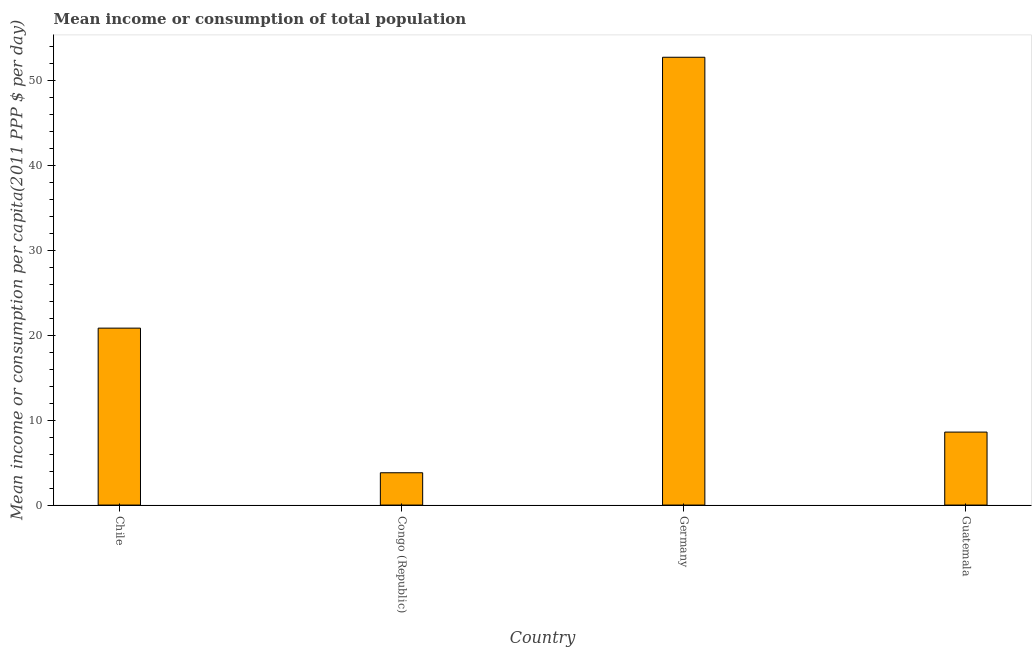Does the graph contain any zero values?
Make the answer very short. No. What is the title of the graph?
Provide a short and direct response. Mean income or consumption of total population. What is the label or title of the X-axis?
Keep it short and to the point. Country. What is the label or title of the Y-axis?
Provide a succinct answer. Mean income or consumption per capita(2011 PPP $ per day). What is the mean income or consumption in Guatemala?
Make the answer very short. 8.6. Across all countries, what is the maximum mean income or consumption?
Offer a very short reply. 52.79. Across all countries, what is the minimum mean income or consumption?
Your answer should be very brief. 3.81. In which country was the mean income or consumption maximum?
Provide a succinct answer. Germany. In which country was the mean income or consumption minimum?
Ensure brevity in your answer.  Congo (Republic). What is the sum of the mean income or consumption?
Offer a terse response. 86.06. What is the difference between the mean income or consumption in Germany and Guatemala?
Ensure brevity in your answer.  44.19. What is the average mean income or consumption per country?
Keep it short and to the point. 21.52. What is the median mean income or consumption?
Keep it short and to the point. 14.73. In how many countries, is the mean income or consumption greater than 24 $?
Your answer should be compact. 1. What is the ratio of the mean income or consumption in Congo (Republic) to that in Germany?
Your response must be concise. 0.07. Is the mean income or consumption in Chile less than that in Congo (Republic)?
Ensure brevity in your answer.  No. Is the difference between the mean income or consumption in Germany and Guatemala greater than the difference between any two countries?
Make the answer very short. No. What is the difference between the highest and the second highest mean income or consumption?
Your response must be concise. 31.93. What is the difference between the highest and the lowest mean income or consumption?
Offer a terse response. 48.98. How many bars are there?
Ensure brevity in your answer.  4. Are all the bars in the graph horizontal?
Give a very brief answer. No. What is the difference between two consecutive major ticks on the Y-axis?
Give a very brief answer. 10. Are the values on the major ticks of Y-axis written in scientific E-notation?
Your response must be concise. No. What is the Mean income or consumption per capita(2011 PPP $ per day) of Chile?
Your answer should be compact. 20.86. What is the Mean income or consumption per capita(2011 PPP $ per day) in Congo (Republic)?
Offer a very short reply. 3.81. What is the Mean income or consumption per capita(2011 PPP $ per day) of Germany?
Keep it short and to the point. 52.79. What is the Mean income or consumption per capita(2011 PPP $ per day) in Guatemala?
Keep it short and to the point. 8.6. What is the difference between the Mean income or consumption per capita(2011 PPP $ per day) in Chile and Congo (Republic)?
Make the answer very short. 17.05. What is the difference between the Mean income or consumption per capita(2011 PPP $ per day) in Chile and Germany?
Offer a very short reply. -31.93. What is the difference between the Mean income or consumption per capita(2011 PPP $ per day) in Chile and Guatemala?
Ensure brevity in your answer.  12.25. What is the difference between the Mean income or consumption per capita(2011 PPP $ per day) in Congo (Republic) and Germany?
Your answer should be very brief. -48.98. What is the difference between the Mean income or consumption per capita(2011 PPP $ per day) in Congo (Republic) and Guatemala?
Provide a succinct answer. -4.79. What is the difference between the Mean income or consumption per capita(2011 PPP $ per day) in Germany and Guatemala?
Your answer should be very brief. 44.19. What is the ratio of the Mean income or consumption per capita(2011 PPP $ per day) in Chile to that in Congo (Republic)?
Your answer should be very brief. 5.47. What is the ratio of the Mean income or consumption per capita(2011 PPP $ per day) in Chile to that in Germany?
Your answer should be compact. 0.4. What is the ratio of the Mean income or consumption per capita(2011 PPP $ per day) in Chile to that in Guatemala?
Offer a terse response. 2.42. What is the ratio of the Mean income or consumption per capita(2011 PPP $ per day) in Congo (Republic) to that in Germany?
Keep it short and to the point. 0.07. What is the ratio of the Mean income or consumption per capita(2011 PPP $ per day) in Congo (Republic) to that in Guatemala?
Offer a very short reply. 0.44. What is the ratio of the Mean income or consumption per capita(2011 PPP $ per day) in Germany to that in Guatemala?
Your answer should be compact. 6.13. 